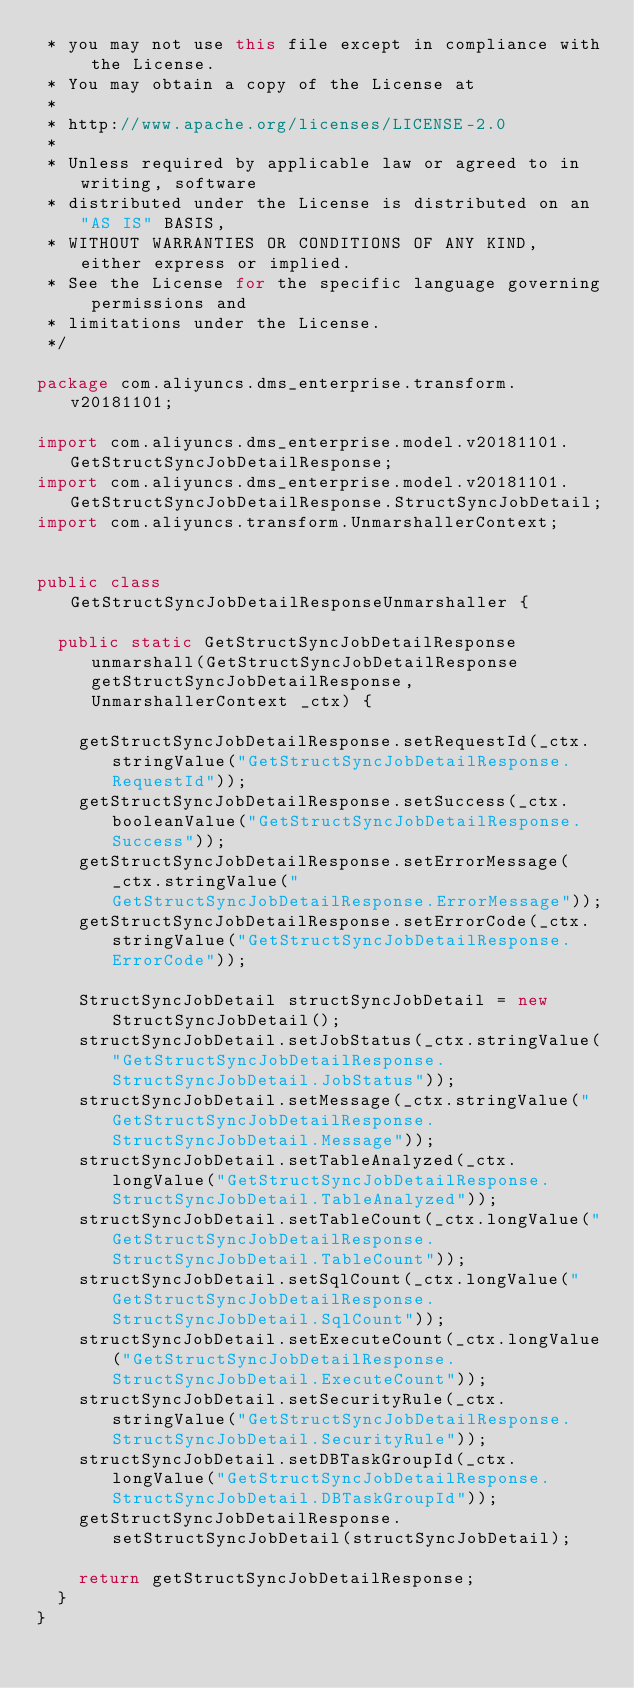<code> <loc_0><loc_0><loc_500><loc_500><_Java_> * you may not use this file except in compliance with the License.
 * You may obtain a copy of the License at
 *
 * http://www.apache.org/licenses/LICENSE-2.0
 *
 * Unless required by applicable law or agreed to in writing, software
 * distributed under the License is distributed on an "AS IS" BASIS,
 * WITHOUT WARRANTIES OR CONDITIONS OF ANY KIND, either express or implied.
 * See the License for the specific language governing permissions and
 * limitations under the License.
 */

package com.aliyuncs.dms_enterprise.transform.v20181101;

import com.aliyuncs.dms_enterprise.model.v20181101.GetStructSyncJobDetailResponse;
import com.aliyuncs.dms_enterprise.model.v20181101.GetStructSyncJobDetailResponse.StructSyncJobDetail;
import com.aliyuncs.transform.UnmarshallerContext;


public class GetStructSyncJobDetailResponseUnmarshaller {

	public static GetStructSyncJobDetailResponse unmarshall(GetStructSyncJobDetailResponse getStructSyncJobDetailResponse, UnmarshallerContext _ctx) {
		
		getStructSyncJobDetailResponse.setRequestId(_ctx.stringValue("GetStructSyncJobDetailResponse.RequestId"));
		getStructSyncJobDetailResponse.setSuccess(_ctx.booleanValue("GetStructSyncJobDetailResponse.Success"));
		getStructSyncJobDetailResponse.setErrorMessage(_ctx.stringValue("GetStructSyncJobDetailResponse.ErrorMessage"));
		getStructSyncJobDetailResponse.setErrorCode(_ctx.stringValue("GetStructSyncJobDetailResponse.ErrorCode"));

		StructSyncJobDetail structSyncJobDetail = new StructSyncJobDetail();
		structSyncJobDetail.setJobStatus(_ctx.stringValue("GetStructSyncJobDetailResponse.StructSyncJobDetail.JobStatus"));
		structSyncJobDetail.setMessage(_ctx.stringValue("GetStructSyncJobDetailResponse.StructSyncJobDetail.Message"));
		structSyncJobDetail.setTableAnalyzed(_ctx.longValue("GetStructSyncJobDetailResponse.StructSyncJobDetail.TableAnalyzed"));
		structSyncJobDetail.setTableCount(_ctx.longValue("GetStructSyncJobDetailResponse.StructSyncJobDetail.TableCount"));
		structSyncJobDetail.setSqlCount(_ctx.longValue("GetStructSyncJobDetailResponse.StructSyncJobDetail.SqlCount"));
		structSyncJobDetail.setExecuteCount(_ctx.longValue("GetStructSyncJobDetailResponse.StructSyncJobDetail.ExecuteCount"));
		structSyncJobDetail.setSecurityRule(_ctx.stringValue("GetStructSyncJobDetailResponse.StructSyncJobDetail.SecurityRule"));
		structSyncJobDetail.setDBTaskGroupId(_ctx.longValue("GetStructSyncJobDetailResponse.StructSyncJobDetail.DBTaskGroupId"));
		getStructSyncJobDetailResponse.setStructSyncJobDetail(structSyncJobDetail);
	 
	 	return getStructSyncJobDetailResponse;
	}
}</code> 